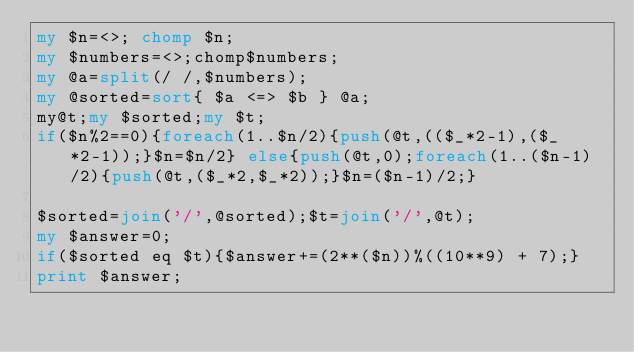<code> <loc_0><loc_0><loc_500><loc_500><_Perl_>my $n=<>; chomp $n;
my $numbers=<>;chomp$numbers;
my @a=split(/ /,$numbers);
my @sorted=sort{ $a <=> $b } @a;
my@t;my $sorted;my $t;
if($n%2==0){foreach(1..$n/2){push(@t,(($_*2-1),($_*2-1));}$n=$n/2} else{push(@t,0);foreach(1..($n-1)/2){push(@t,($_*2,$_*2));}$n=($n-1)/2;}

$sorted=join('/',@sorted);$t=join('/',@t);
my $answer=0;
if($sorted eq $t){$answer+=(2**($n))%((10**9) + 7);}
print $answer;</code> 